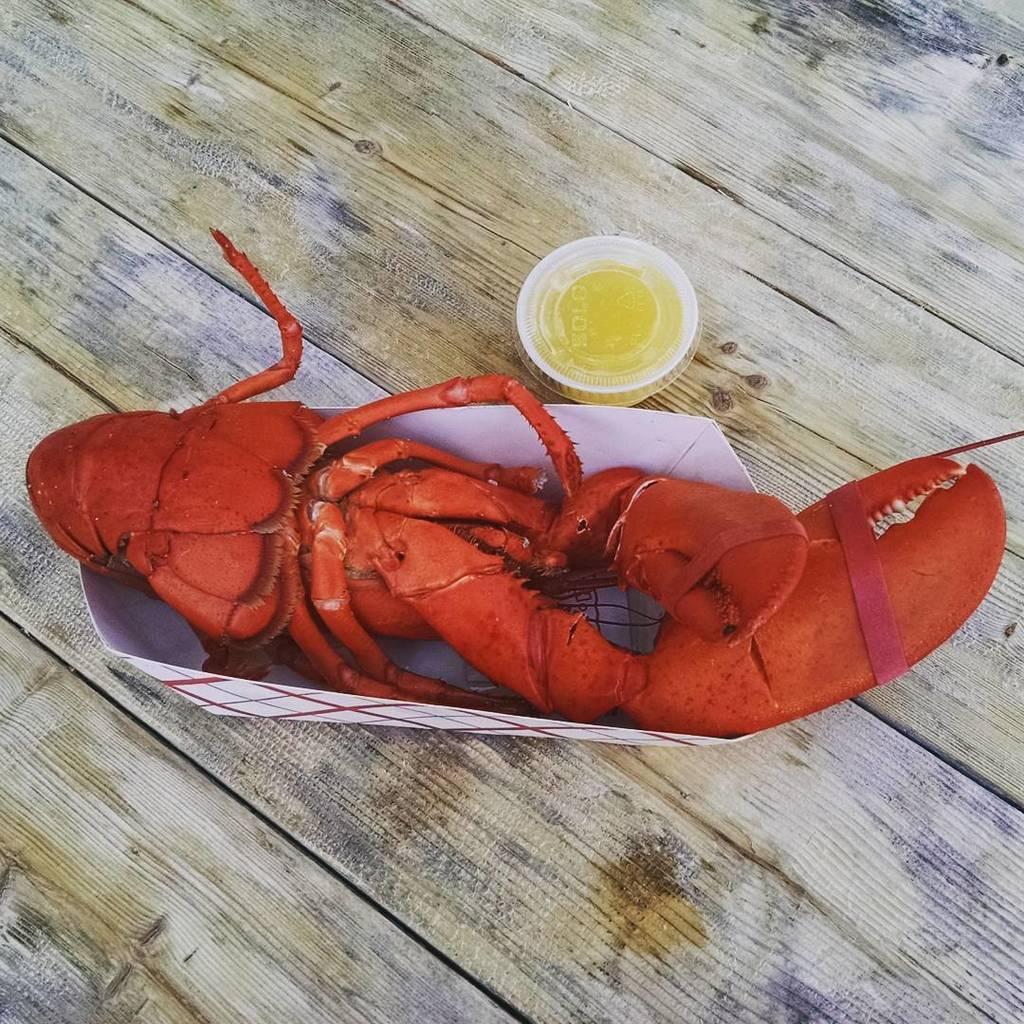In one or two sentences, can you explain what this image depicts? In this image there is a table on which we can see there is a crab served in paper bowl beside that there is a sauce packet. 